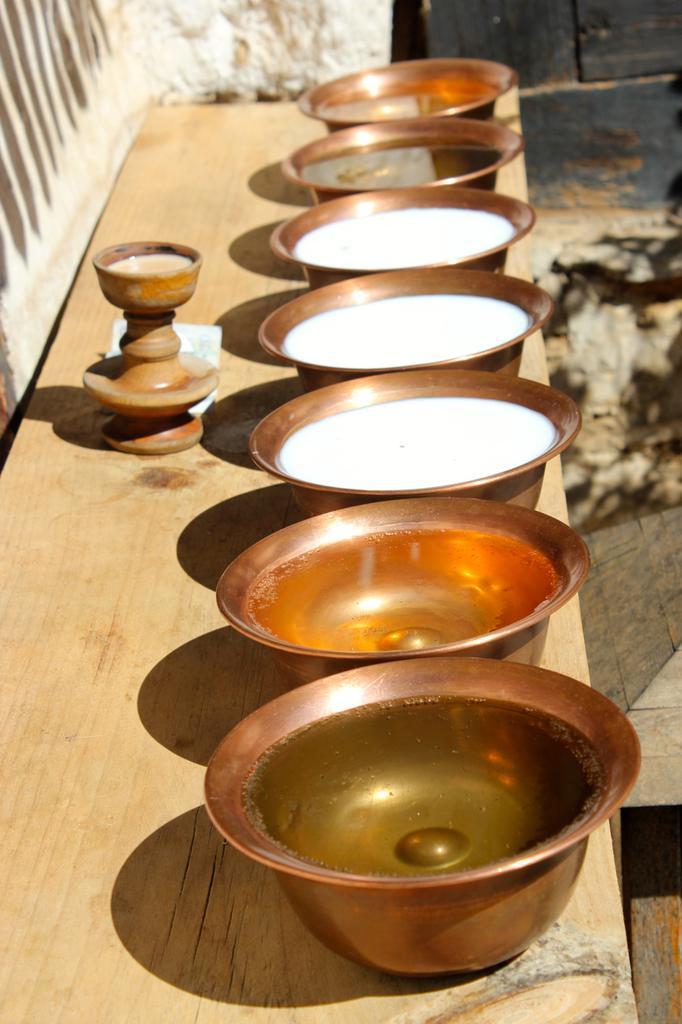Can you describe this image briefly? In this picture there are bowls. In the bowels it looks like milk and oil. At the back there is a wall. 